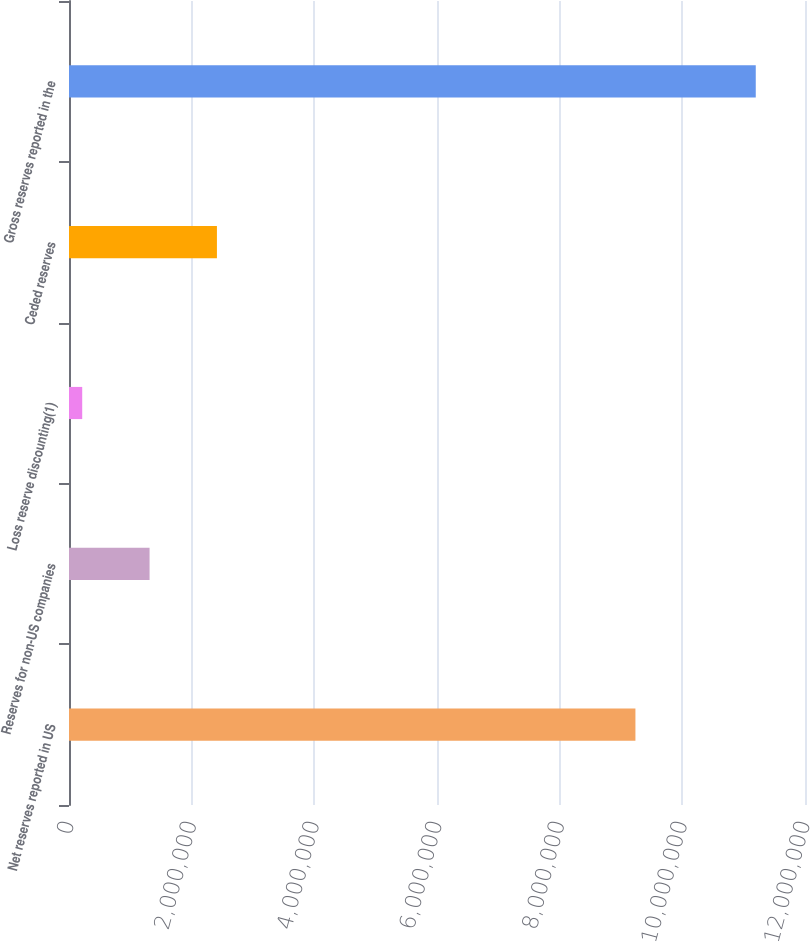Convert chart to OTSL. <chart><loc_0><loc_0><loc_500><loc_500><bar_chart><fcel>Net reserves reported in US<fcel>Reserves for non-US companies<fcel>Loss reserve discounting(1)<fcel>Ceded reserves<fcel>Gross reserves reported in the<nl><fcel>9.23521e+06<fcel>1.31367e+06<fcel>215502<fcel>2.41184e+06<fcel>1.11972e+07<nl></chart> 